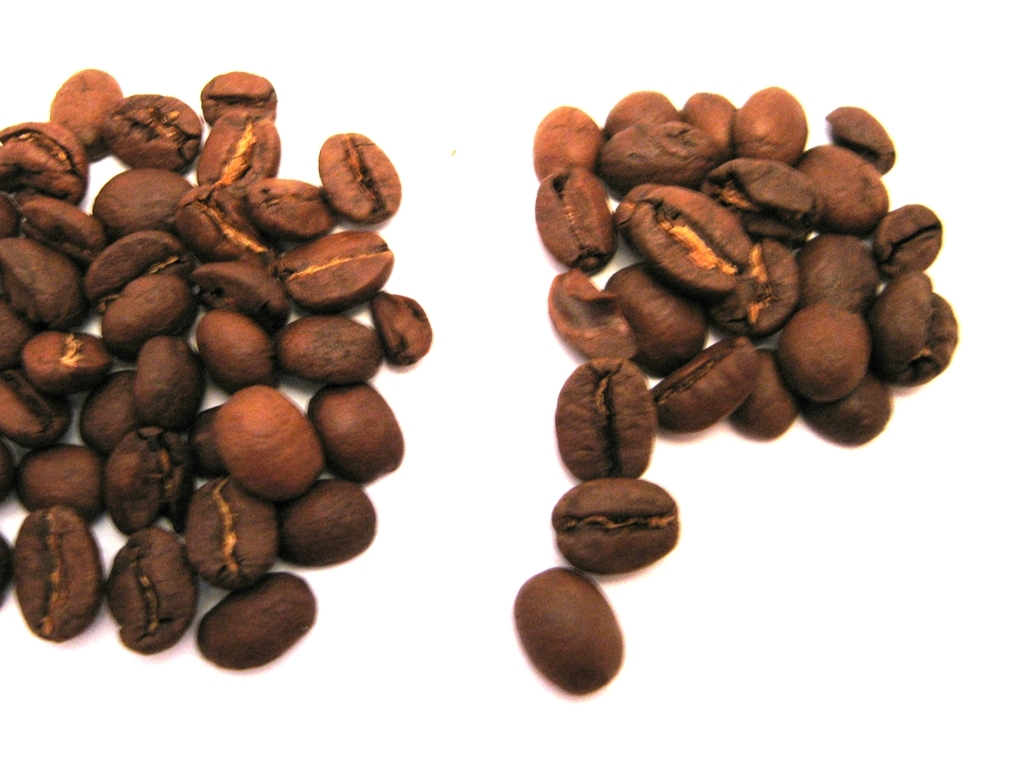Can you tell me more about the types of coffee beans shown in this image? Certainly! The image displays two groups of roasted coffee beans, likely representing different roast levels or bean varieties. The variations in color and shape indicate that they may come from different origins or possess unique flavor profiles, often influenced by their growing conditions and post-harvest processing methods. How does the roast level affect the flavor of the beans? The roast level has a significant impact on flavor. Lighter roasts tend to preserve more of the bean's original character and subtle flavors, which can include fruity or floral notes. Darker roasts often have a bold, more robust flavor with a pronounced bitterness and less acidity, which can bring out chocolatey or nutty notes. 